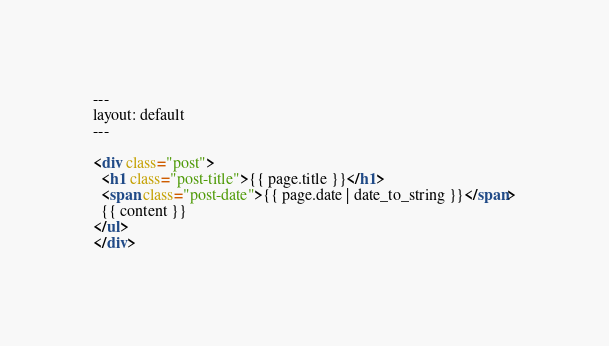Convert code to text. <code><loc_0><loc_0><loc_500><loc_500><_HTML_>---
layout: default
---

<div class="post">
  <h1 class="post-title">{{ page.title }}</h1>
  <span class="post-date">{{ page.date | date_to_string }}</span>
  {{ content }}
</ul>
</div>
</code> 